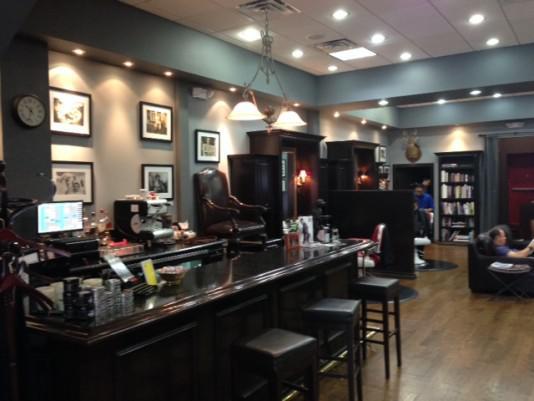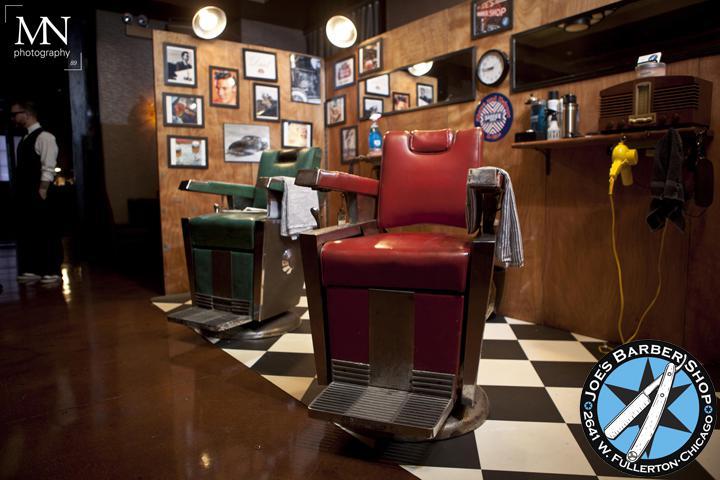The first image is the image on the left, the second image is the image on the right. For the images displayed, is the sentence "One image has exactly two barber chairs." factually correct? Answer yes or no. Yes. The first image is the image on the left, the second image is the image on the right. For the images shown, is this caption "At least one of the images prominently features the storefront of a Barber Shop." true? Answer yes or no. No. 